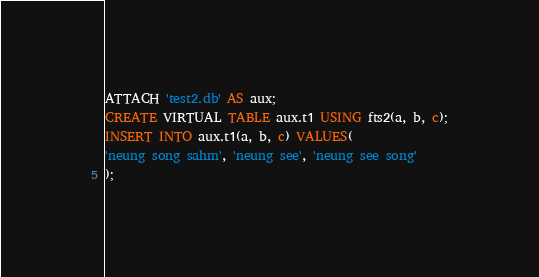Convert code to text. <code><loc_0><loc_0><loc_500><loc_500><_SQL_>ATTACH 'test2.db' AS aux;
CREATE VIRTUAL TABLE aux.t1 USING fts2(a, b, c);
INSERT INTO aux.t1(a, b, c) VALUES(
'neung song sahm', 'neung see', 'neung see song'
);</code> 